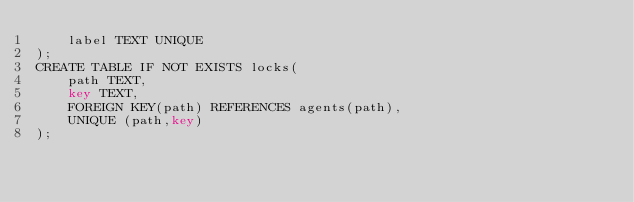<code> <loc_0><loc_0><loc_500><loc_500><_SQL_>    label TEXT UNIQUE
);
CREATE TABLE IF NOT EXISTS locks(
    path TEXT,
    key TEXT,
    FOREIGN KEY(path) REFERENCES agents(path),
    UNIQUE (path,key)
);
</code> 